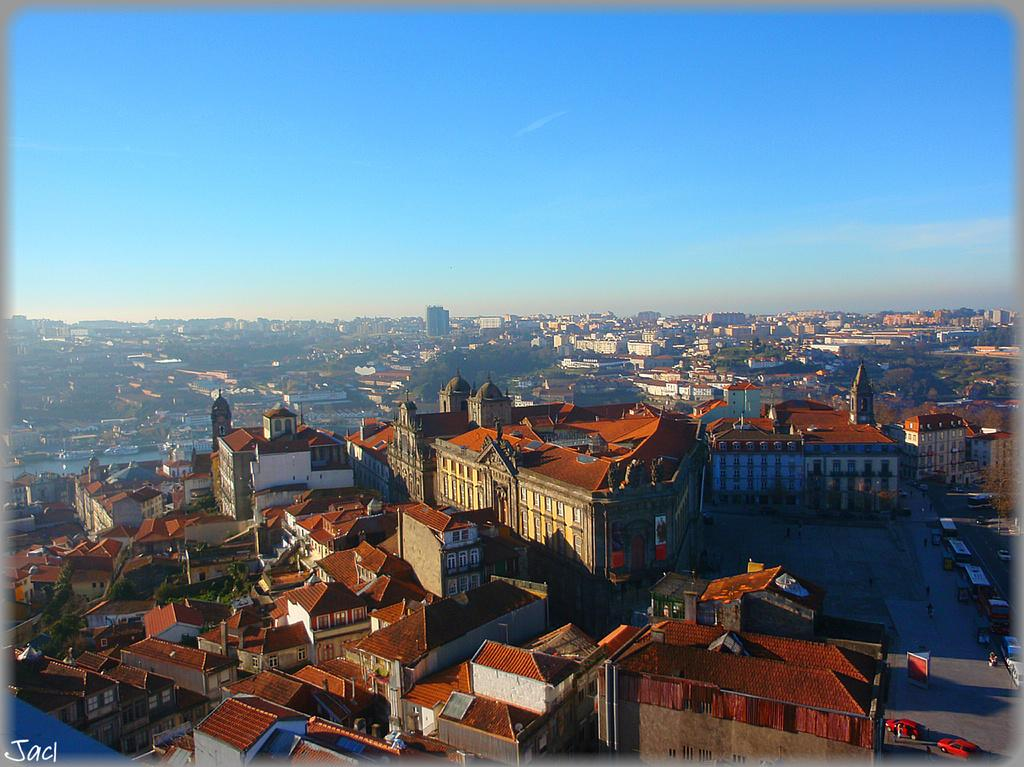What type of structures can be seen in the image? There are many buildings with windows in the image. What can be seen in the background of the image? The sky is visible in the background of the image. What else is present in the image besides buildings? There are vehicles in the image. Is there any text visible in the image? Yes, there is text written in the left bottom corner of the image. What type of eggs can be seen on the tray in the image? There is no tray or eggs present in the image. 